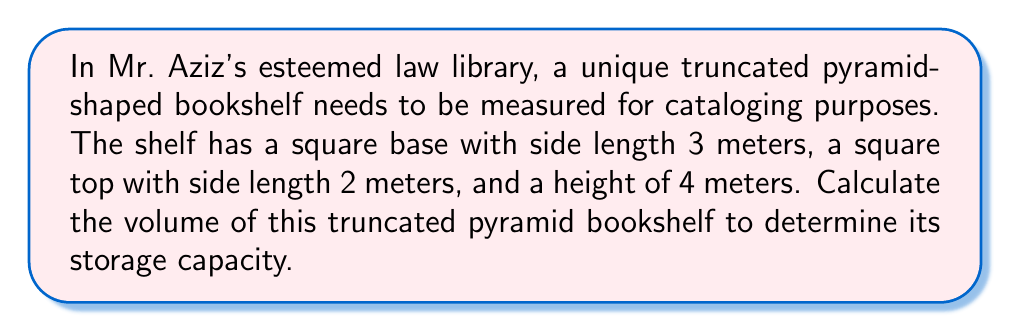Solve this math problem. To calculate the volume of a truncated pyramid, we'll use the formula:

$$V = \frac{1}{3}h(a^2 + ab + b^2)$$

Where:
$V$ = volume
$h$ = height of the truncated pyramid
$a$ = side length of the base
$b$ = side length of the top

Given:
$h = 4$ meters
$a = 3$ meters
$b = 2$ meters

Let's substitute these values into the formula:

$$V = \frac{1}{3} \cdot 4(3^2 + 3 \cdot 2 + 2^2)$$

Now, let's solve step by step:

1) First, calculate the terms inside the parentheses:
   $3^2 = 9$
   $3 \cdot 2 = 6$
   $2^2 = 4$

2) Add these terms:
   $9 + 6 + 4 = 19$

3) Multiply by the height:
   $4 \cdot 19 = 76$

4) Finally, multiply by $\frac{1}{3}$:
   $\frac{1}{3} \cdot 76 = \frac{76}{3} = 25.3333...$

Therefore, the volume of the truncated pyramid bookshelf is approximately 25.33 cubic meters.

[asy]
import three;

size(200);
currentprojection=perspective(6,3,2);

triple A=(0,0,0), B=(3,0,0), C=(3,3,0), D=(0,3,0);
triple E=(0.5,0.5,4), F=(2.5,0.5,4), G=(2.5,2.5,4), H=(0.5,2.5,4);

draw(A--B--C--D--cycle);
draw(E--F--G--H--cycle);
draw(A--E);
draw(B--F);
draw(C--G);
draw(D--H);

label("3m", (B+C)/2, S);
label("2m", (F+G)/2, N);
label("4m", (A+E)/2, W);
[/asy]
Answer: $25.33$ cubic meters 